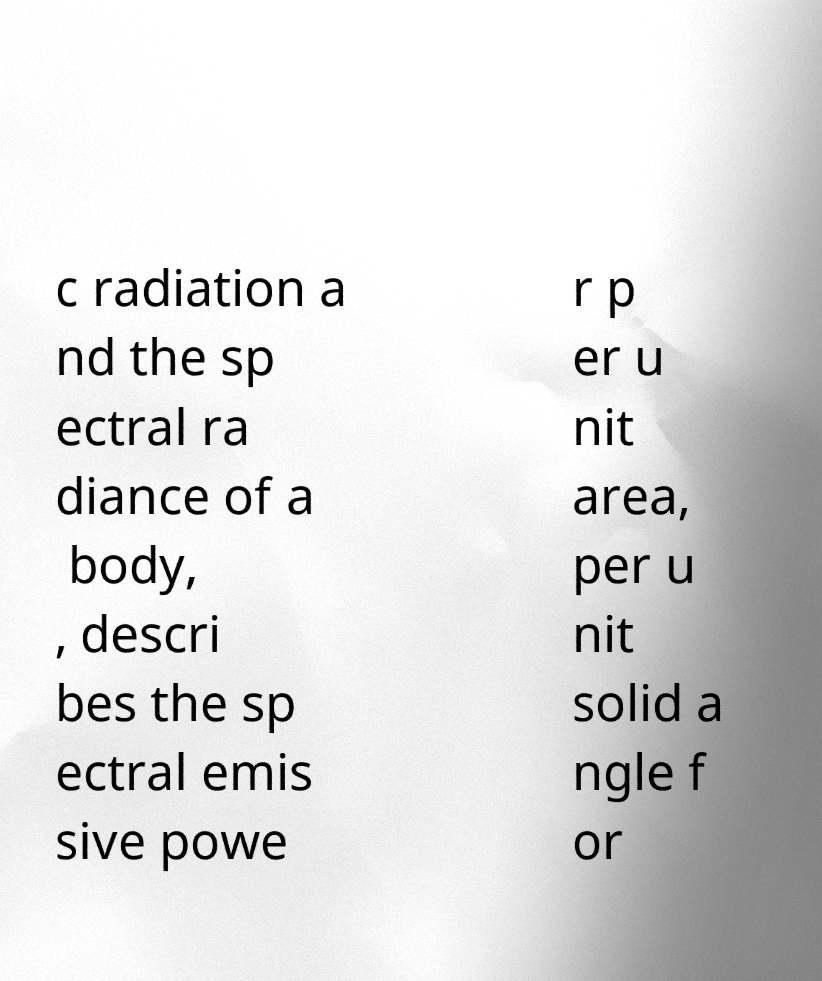Please identify and transcribe the text found in this image. c radiation a nd the sp ectral ra diance of a body, , descri bes the sp ectral emis sive powe r p er u nit area, per u nit solid a ngle f or 